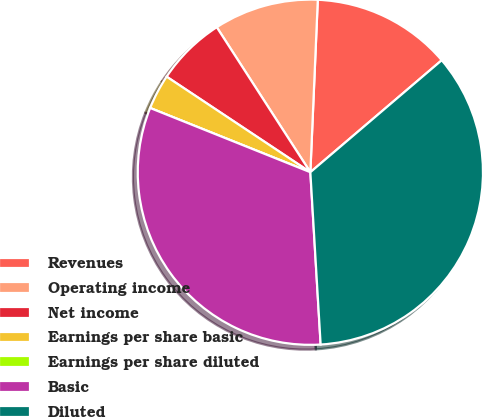<chart> <loc_0><loc_0><loc_500><loc_500><pie_chart><fcel>Revenues<fcel>Operating income<fcel>Net income<fcel>Earnings per share basic<fcel>Earnings per share diluted<fcel>Basic<fcel>Diluted<nl><fcel>13.08%<fcel>9.81%<fcel>6.54%<fcel>3.27%<fcel>0.0%<fcel>32.02%<fcel>35.29%<nl></chart> 